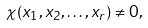Convert formula to latex. <formula><loc_0><loc_0><loc_500><loc_500>\chi ( x _ { 1 } , x _ { 2 } , \dots , x _ { r } ) \neq 0 ,</formula> 